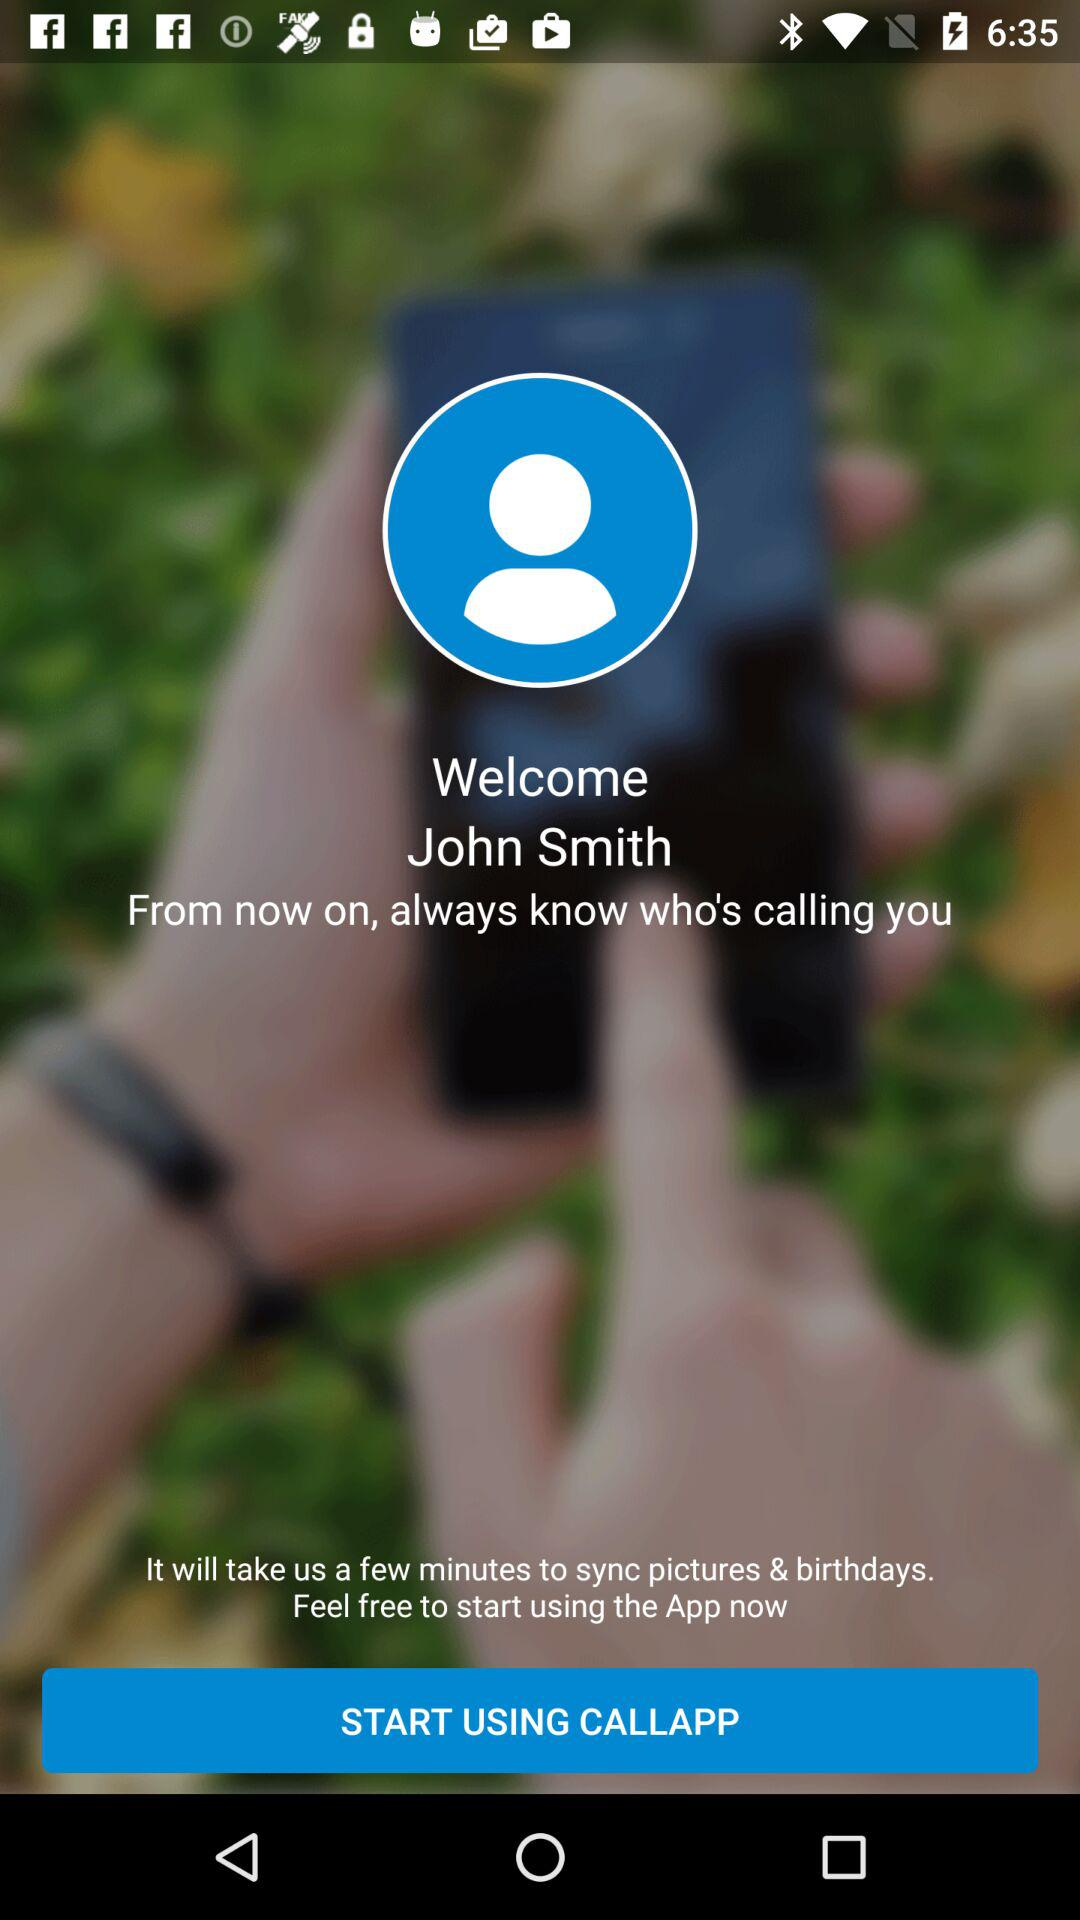What is the name of the application? The name of the application is "CALLAPP". 